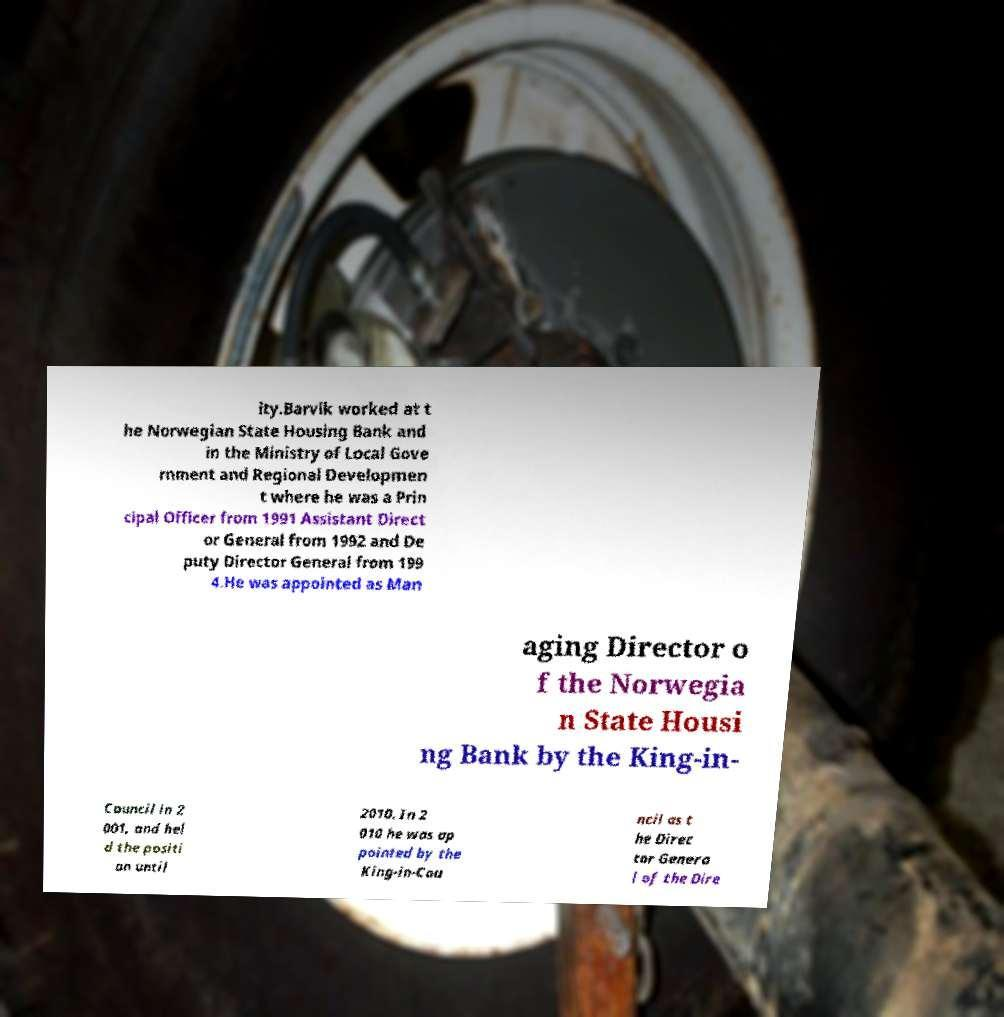Could you extract and type out the text from this image? ity.Barvik worked at t he Norwegian State Housing Bank and in the Ministry of Local Gove rnment and Regional Developmen t where he was a Prin cipal Officer from 1991 Assistant Direct or General from 1992 and De puty Director General from 199 4.He was appointed as Man aging Director o f the Norwegia n State Housi ng Bank by the King-in- Council in 2 001, and hel d the positi on until 2010. In 2 010 he was ap pointed by the King-in-Cou ncil as t he Direc tor Genera l of the Dire 